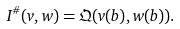Convert formula to latex. <formula><loc_0><loc_0><loc_500><loc_500>I ^ { \# } ( v , w ) = \mathfrak Q ( v ( b ) , w ( b ) ) .</formula> 